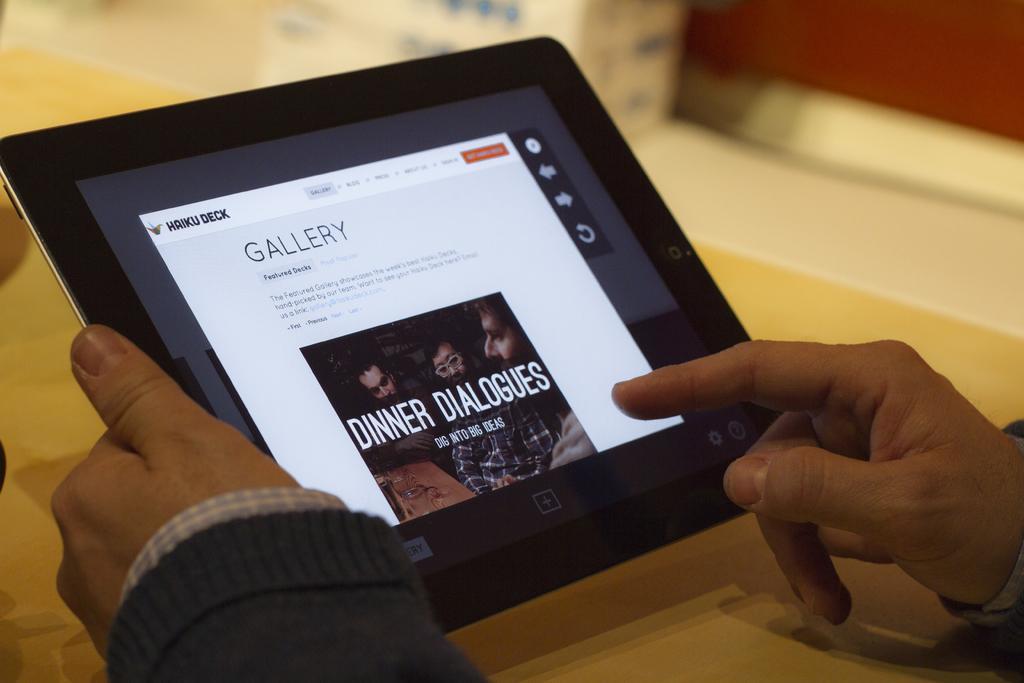How would you summarize this image in a sentence or two? Here in this picture we can see a person's hands and he is carrying a tablet and handling it and in front of him we can see a table present. 